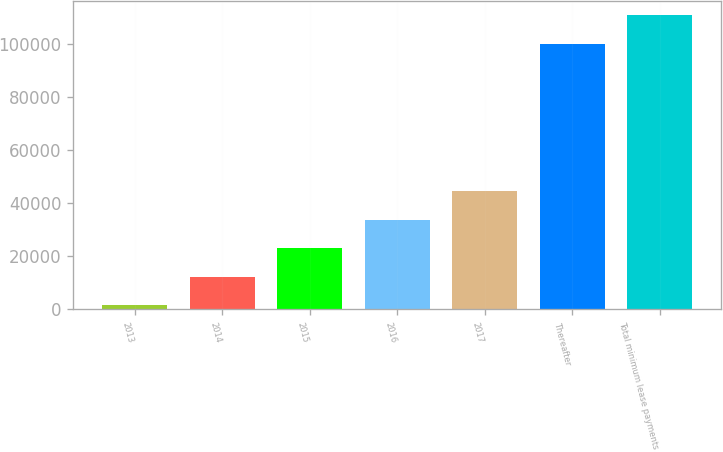Convert chart to OTSL. <chart><loc_0><loc_0><loc_500><loc_500><bar_chart><fcel>2013<fcel>2014<fcel>2015<fcel>2016<fcel>2017<fcel>Thereafter<fcel>Total minimum lease payments<nl><fcel>1555<fcel>12269<fcel>22983<fcel>33697<fcel>44411<fcel>99828<fcel>110542<nl></chart> 